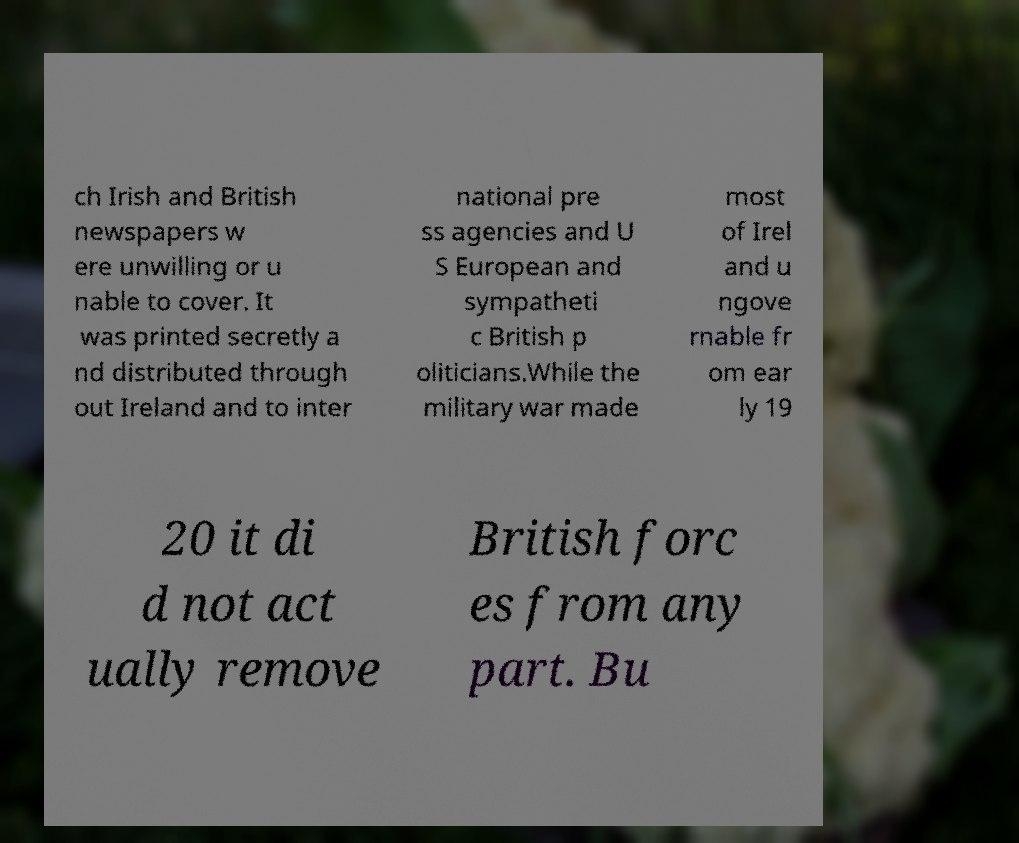Can you read and provide the text displayed in the image?This photo seems to have some interesting text. Can you extract and type it out for me? ch Irish and British newspapers w ere unwilling or u nable to cover. It was printed secretly a nd distributed through out Ireland and to inter national pre ss agencies and U S European and sympatheti c British p oliticians.While the military war made most of Irel and u ngove rnable fr om ear ly 19 20 it di d not act ually remove British forc es from any part. Bu 